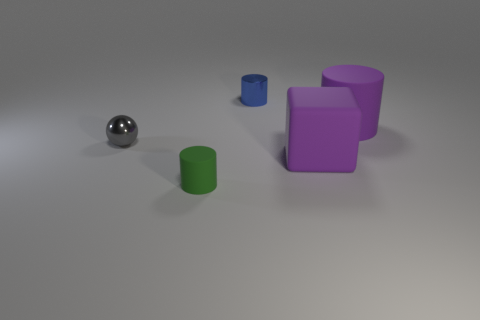Subtract all red spheres. Subtract all cyan blocks. How many spheres are left? 1 Add 1 tiny blue metallic things. How many objects exist? 6 Subtract all cylinders. How many objects are left? 2 Add 5 blue cylinders. How many blue cylinders exist? 6 Subtract 0 red cubes. How many objects are left? 5 Subtract all small things. Subtract all purple blocks. How many objects are left? 1 Add 2 tiny things. How many tiny things are left? 5 